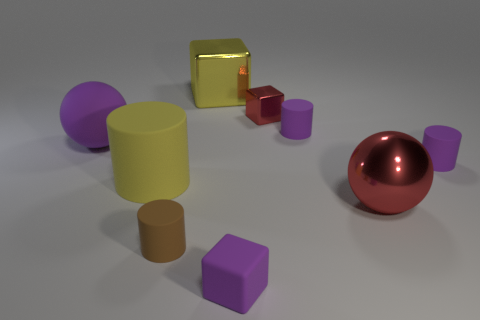What is the color of the big sphere that is on the left side of the red object left of the large metallic sphere?
Your answer should be very brief. Purple. Is the purple block the same size as the red shiny block?
Keep it short and to the point. Yes. Does the cube behind the small metal cube have the same material as the large thing in front of the large cylinder?
Make the answer very short. Yes. The red object that is behind the purple thing right of the big sphere in front of the yellow rubber thing is what shape?
Give a very brief answer. Cube. Are there more tiny red blocks than tiny brown metal cylinders?
Ensure brevity in your answer.  Yes. Is there a large metal sphere?
Your response must be concise. Yes. How many objects are either small matte cylinders that are on the right side of the large yellow block or small matte objects in front of the red metallic sphere?
Your answer should be compact. 4. Do the metal ball and the large metal block have the same color?
Your answer should be compact. No. Are there fewer big gray cubes than small purple matte blocks?
Provide a succinct answer. Yes. There is a rubber sphere; are there any tiny red things on the left side of it?
Offer a very short reply. No. 